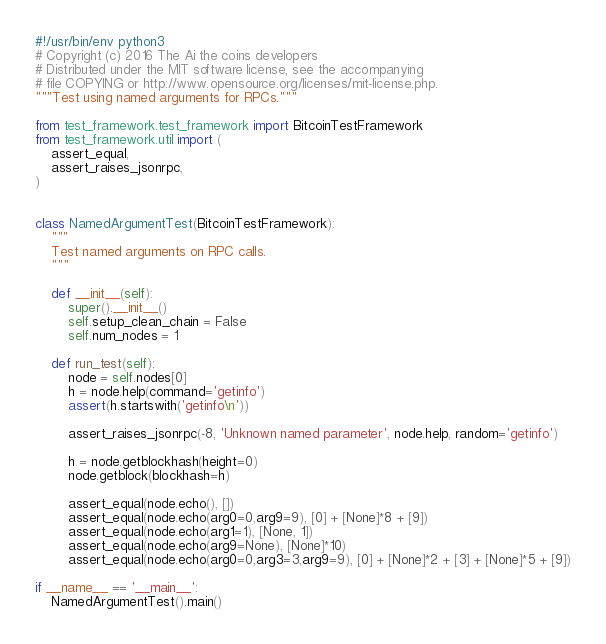Convert code to text. <code><loc_0><loc_0><loc_500><loc_500><_Python_>#!/usr/bin/env python3
# Copyright (c) 2016 The Ai the coins developers
# Distributed under the MIT software license, see the accompanying
# file COPYING or http://www.opensource.org/licenses/mit-license.php.
"""Test using named arguments for RPCs."""

from test_framework.test_framework import BitcoinTestFramework
from test_framework.util import (
    assert_equal,
    assert_raises_jsonrpc,
)


class NamedArgumentTest(BitcoinTestFramework):
    """
    Test named arguments on RPC calls.
    """

    def __init__(self):
        super().__init__()
        self.setup_clean_chain = False
        self.num_nodes = 1

    def run_test(self):
        node = self.nodes[0]
        h = node.help(command='getinfo')
        assert(h.startswith('getinfo\n'))

        assert_raises_jsonrpc(-8, 'Unknown named parameter', node.help, random='getinfo')

        h = node.getblockhash(height=0)
        node.getblock(blockhash=h)

        assert_equal(node.echo(), [])
        assert_equal(node.echo(arg0=0,arg9=9), [0] + [None]*8 + [9])
        assert_equal(node.echo(arg1=1), [None, 1])
        assert_equal(node.echo(arg9=None), [None]*10)
        assert_equal(node.echo(arg0=0,arg3=3,arg9=9), [0] + [None]*2 + [3] + [None]*5 + [9])

if __name__ == '__main__':
    NamedArgumentTest().main()
</code> 